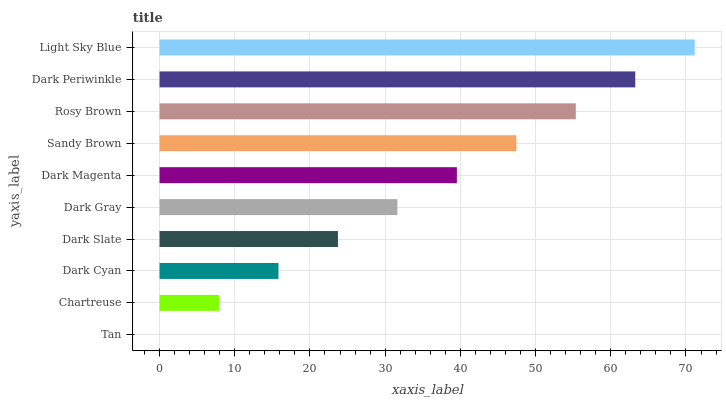Is Tan the minimum?
Answer yes or no. Yes. Is Light Sky Blue the maximum?
Answer yes or no. Yes. Is Chartreuse the minimum?
Answer yes or no. No. Is Chartreuse the maximum?
Answer yes or no. No. Is Chartreuse greater than Tan?
Answer yes or no. Yes. Is Tan less than Chartreuse?
Answer yes or no. Yes. Is Tan greater than Chartreuse?
Answer yes or no. No. Is Chartreuse less than Tan?
Answer yes or no. No. Is Dark Magenta the high median?
Answer yes or no. Yes. Is Dark Gray the low median?
Answer yes or no. Yes. Is Light Sky Blue the high median?
Answer yes or no. No. Is Tan the low median?
Answer yes or no. No. 